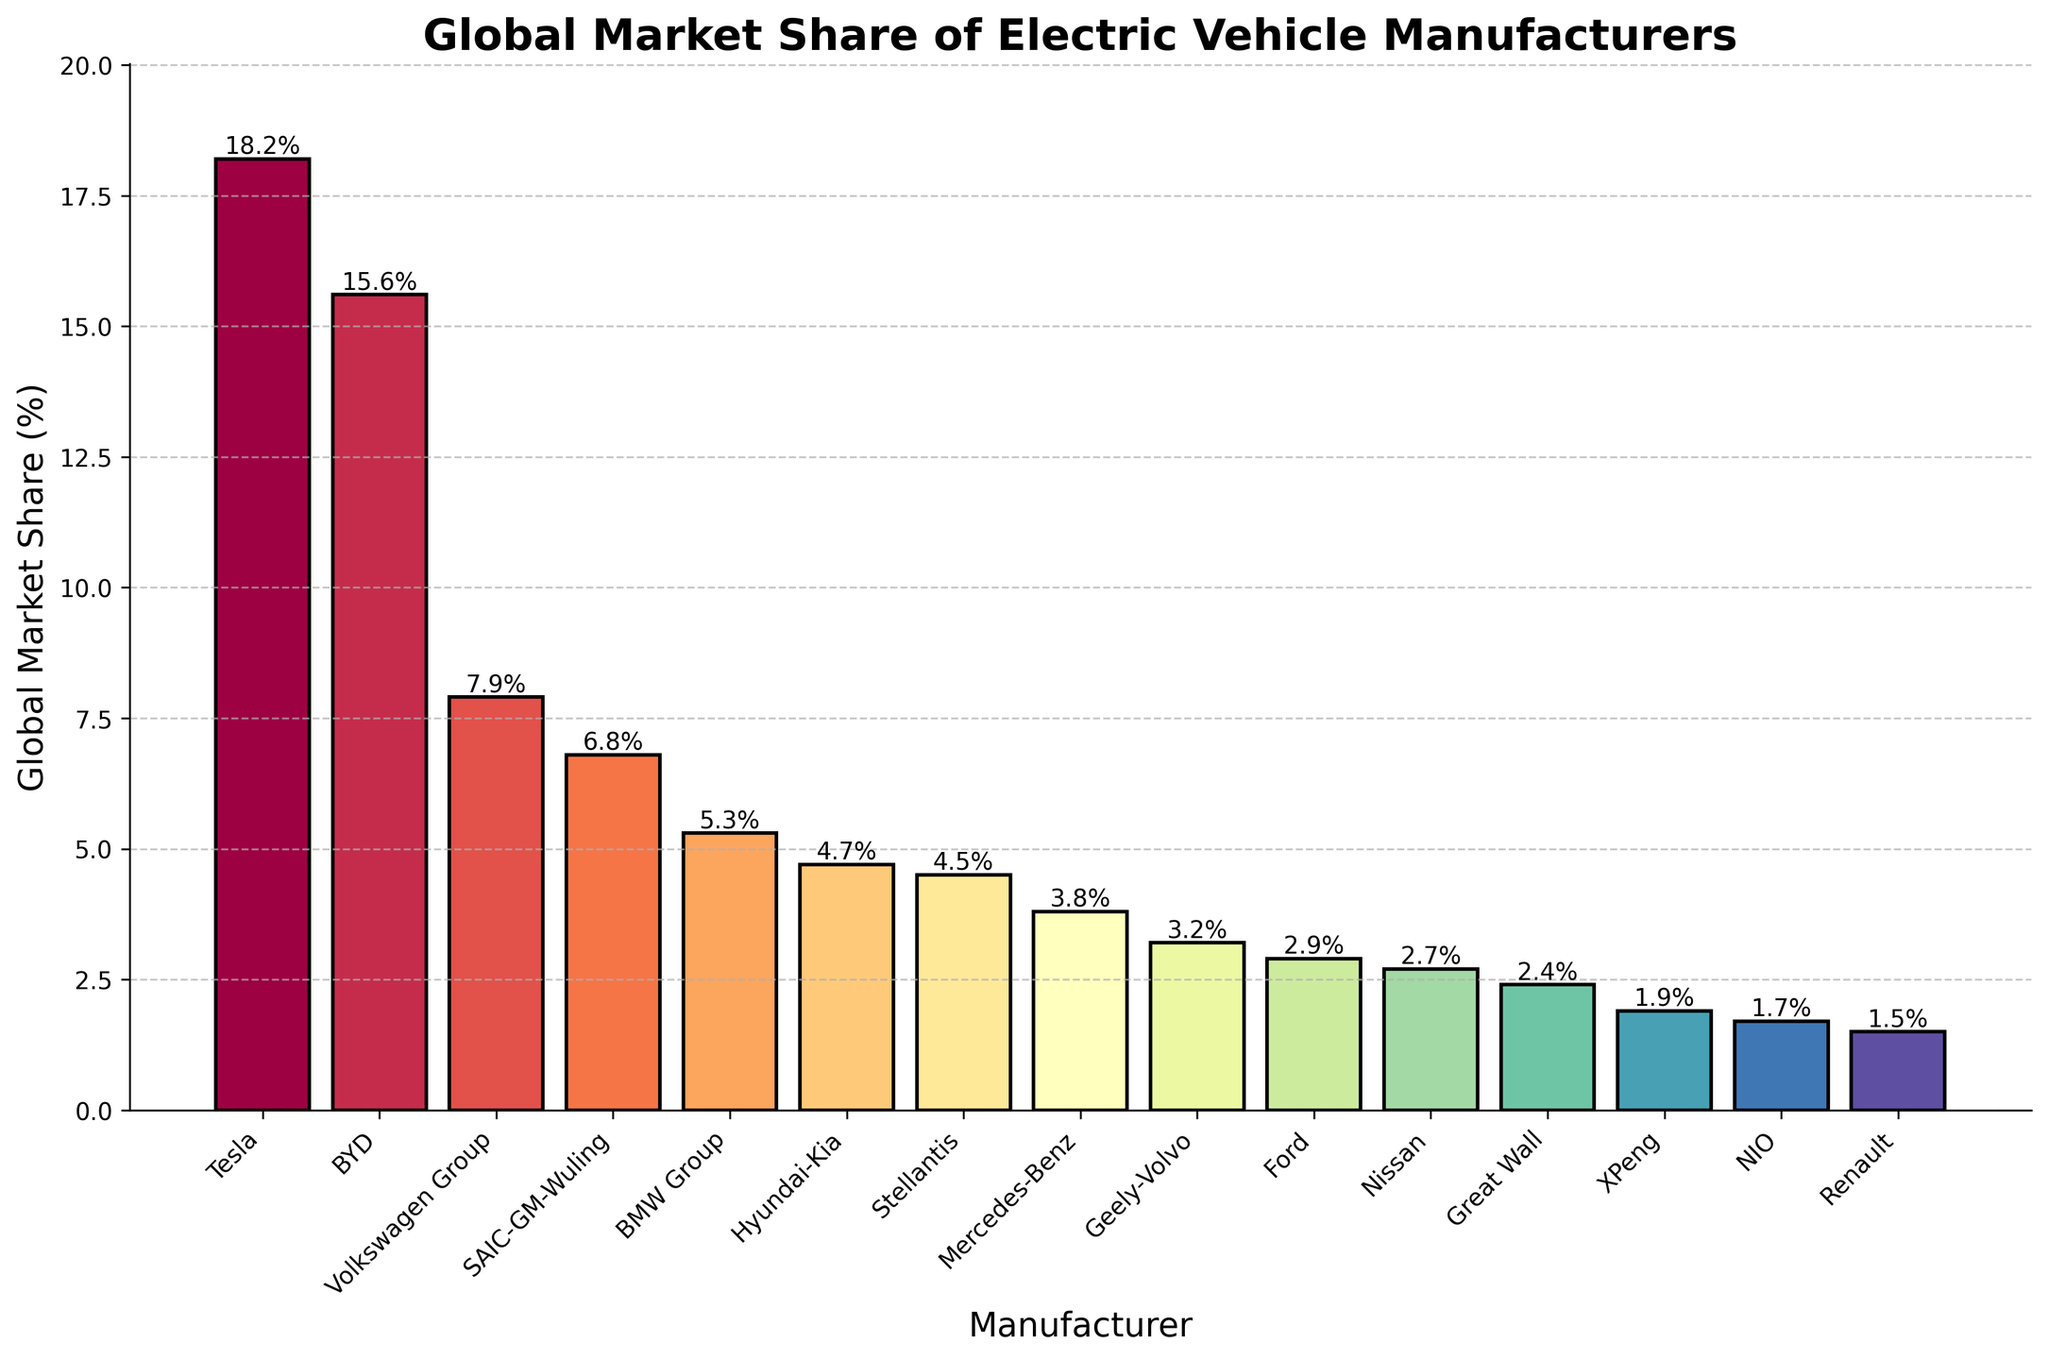What's the combined market share of BYD and Tesla? To find the combined market share, add the percentages of BYD (15.6%) and Tesla (18.2%). 15.6% + 18.2% = 33.8%
Answer: 33.8% Among BMW Group, Hyundai-Kia, and Stellantis, which manufacturer has the highest market share? Compare their market shares: BMW Group (5.3%), Hyundai-Kia (4.7%), and Stellantis (4.5%). BMW Group has the highest market share at 5.3%.
Answer: BMW Group How much larger is Tesla's market share compared to Ford's? Subtract Ford's market share (2.9%) from Tesla's market share (18.2%). 18.2% - 2.9% = 15.3%
Answer: 15.3% Is the market share of SAIC-GM-Wuling more than double that of Nissan? Compare SAIC-GM-Wuling's market share (6.8%) with twice the market share of Nissan (2.7% * 2 = 5.4%). Since 6.8% > 5.4%, SAIC-GM-Wuling's market share is more than double Nissan's.
Answer: Yes What is the average market share of the bottom five manufacturers? Add the market shares of XPeng (1.9%), NIO (1.7%), Renault (1.5%), Great Wall (2.4%), and Nissan (2.7%). Sum = 1.9% + 1.7% + 1.5% + 2.4% + 2.7% = 10.2%. Divide the sum by 5 to get the average: 10.2% / 5 = 2.04%
Answer: 2.04% What is the difference in market share between Mercedes-Benz and Geely-Volvo? Subtract Geely-Volvo's market share (3.2%) from Mercedes-Benz's market share (3.8%). 3.8% - 3.2% = 0.6%
Answer: 0.6% Which manufacturer falls into the middle of the market in terms of market share and what is its value? To find the median market share, sort the manufacturers by their market shares and find the middle one (8th entry). The middle manufacturer is Mercedes-Benz with 3.8%.
Answer: Mercedes-Benz, 3.8% What is the sum of the market shares of all manufacturers not in the top 3? Subtract the sum of the top 3 manufacturers (Tesla 18.2% + BYD 15.6% + Volkswagen Group 7.9%) from 100%. Sum of top 3 = 41.7%, so 100% - 41.7% = 58.3%
Answer: 58.3% 